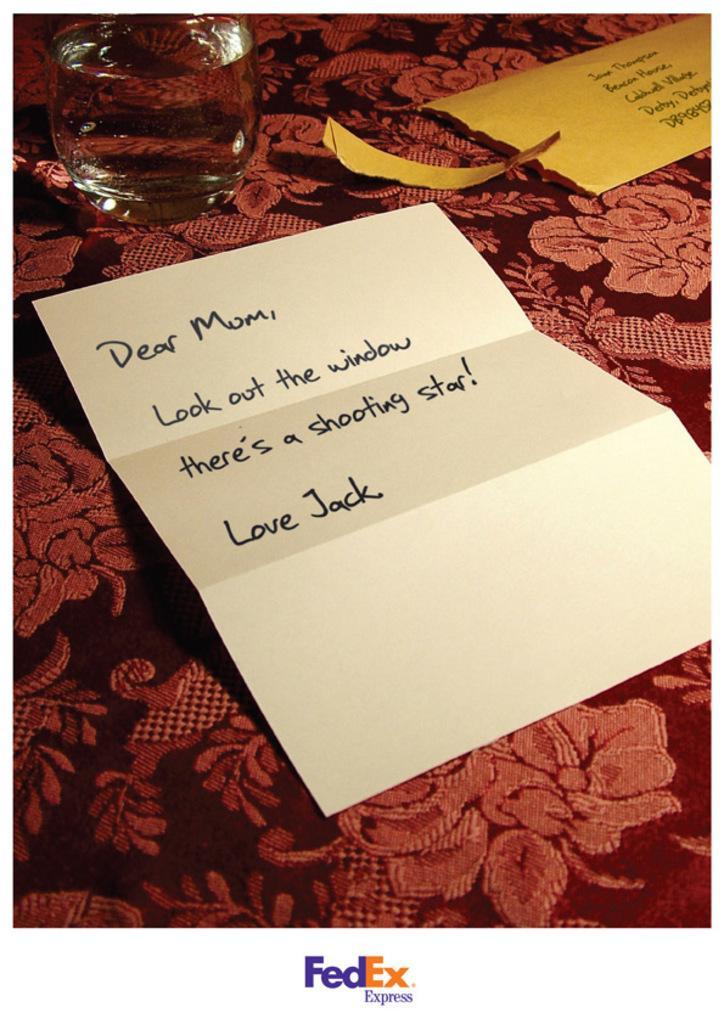Can you describe this image briefly? Here we can see a glass and papers on the cloth. 